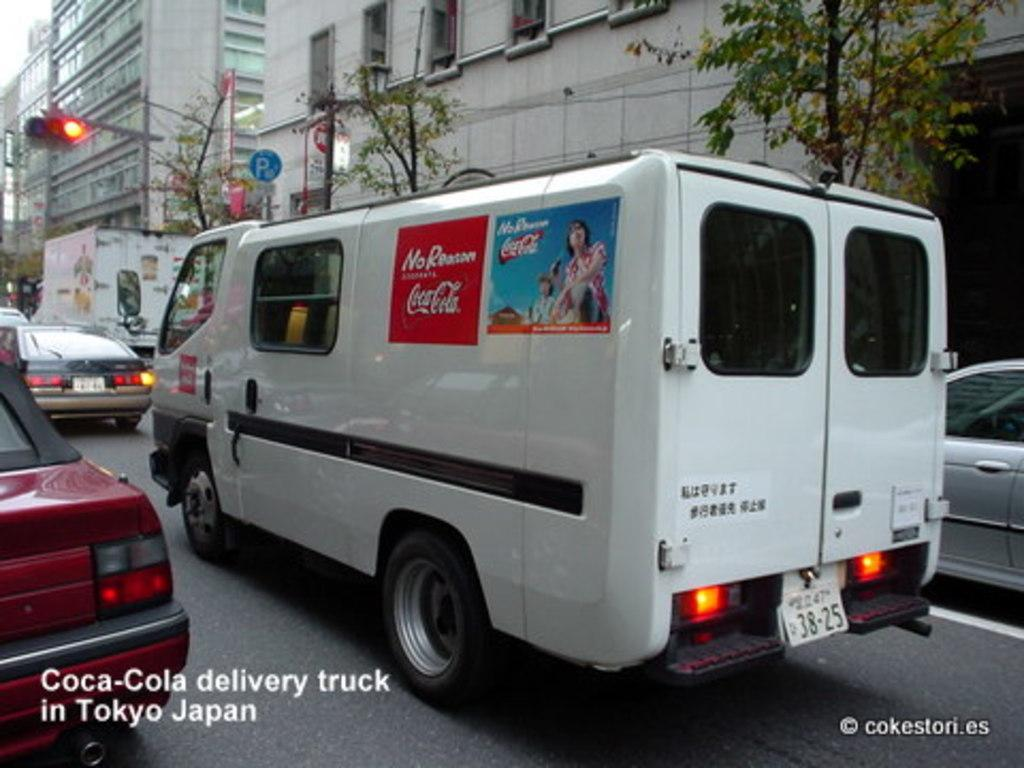<image>
Provide a brief description of the given image. A van is branded with two Coca-Cola advertisements. 